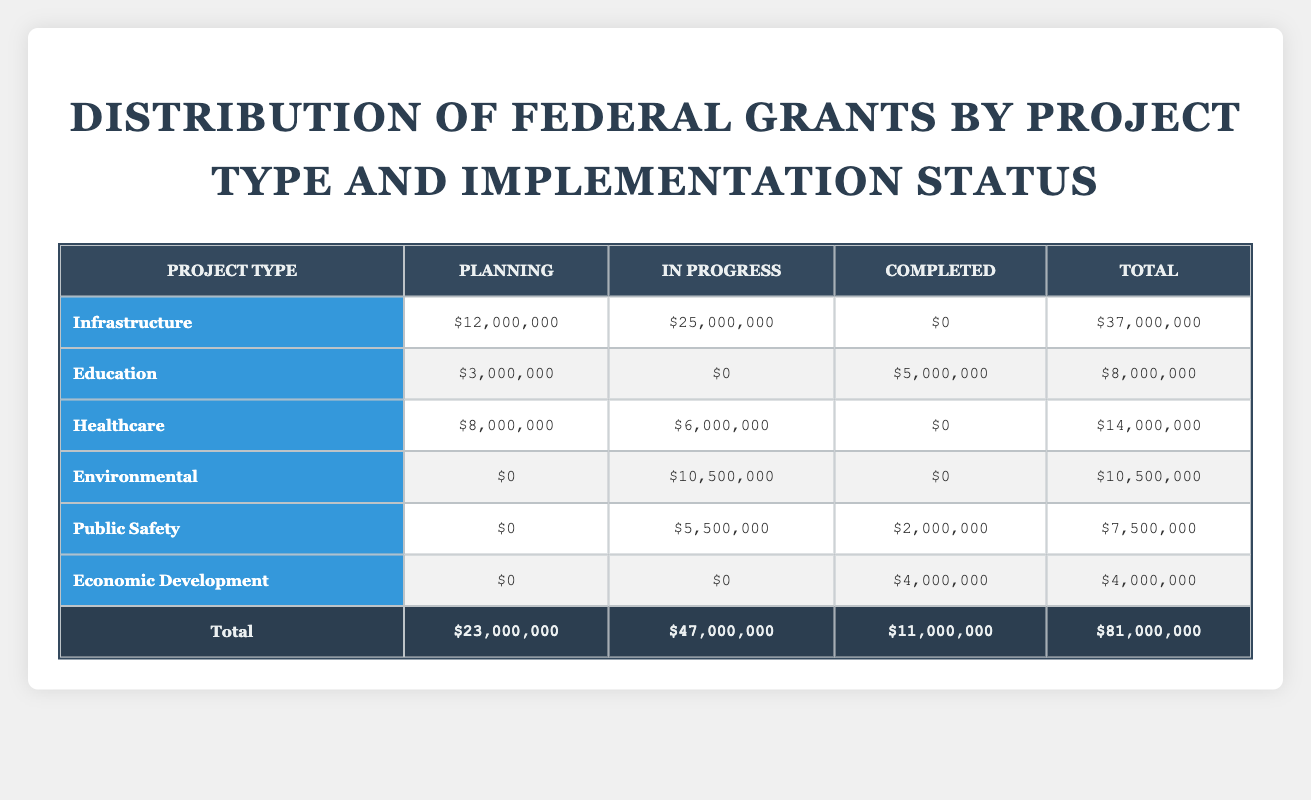What's the total grant amount for Infrastructure projects? To find the total grant amount for Infrastructure projects, we look at the row under the "Infrastructure" project type. The values for each implementation status are $12,000,000 for Planning, $25,000,000 for In Progress, and $0 for Completed. Adding these gives us $12,000,000 + $25,000,000 + $0 = $37,000,000.
Answer: 37,000,000 How much funding was allocated to Healthcare projects that are In Progress? In the row for Healthcare, the funding amount for projects In Progress is noted as $6,000,000. This is a direct retrieval from the table.
Answer: 6,000,000 Did any project type receive no funding for the Planning status? Inspecting each project type, we see that Environmental and Public Safety both have $0 allocated for Planning. Thus, the answer to the question is yes.
Answer: Yes What is the total amount for completed projects across all project types? To find the total for completed projects, we sum the values in the Completed column across all project types: $0 (Infrastructure) + $5,000,000 (Education) + $0 (Healthcare) + $0 (Environmental) + $2,000,000 (Public Safety) + $4,000,000 (Economic Development) = $11,000,000.
Answer: 11,000,000 Which project type has the highest total grant amount overall? We need to summarize the total for each project type from the Total column: Infrastructure = $37,000,000, Education = $8,000,000, Healthcare = $14,000,000, Environmental = $10,500,000, Public Safety = $7,500,000, and Economic Development = $4,000,000. The highest is Infrastructure with $37,000,000.
Answer: Infrastructure How much total funding was allocated to all Environmental projects? Looking at the Environmental project type, we see $0 for Planning, $10,500,000 for In Progress, and $0 for Completed. Summing these amounts gives $0 + $10,500,000 + $0 = $10,500,000.
Answer: 10,500,000 Is it true that the total amount for Planning projects is equal to the total amount for Completed projects? We first find the total funding for Planning projects, which is $23,000,000. Then we look for the total for Completed projects which is $11,000,000. Since $23,000,000 is not equal to $11,000,000, the answer is false.
Answer: No What percentage of total funding is allocated to In Progress projects? The total amount for In Progress is $47,000,000, and the overall total is $81,000,000. To find the percentage, we calculate (47,000,000 / 81,000,000) * 100, which is approximately 58.02%.
Answer: 58.02% 